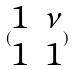Convert formula to latex. <formula><loc_0><loc_0><loc_500><loc_500>( \begin{matrix} 1 & \nu \\ 1 & 1 \end{matrix} )</formula> 